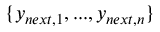<formula> <loc_0><loc_0><loc_500><loc_500>\{ y _ { n e x t , 1 } , \dots , y _ { n e x t , n } \}</formula> 